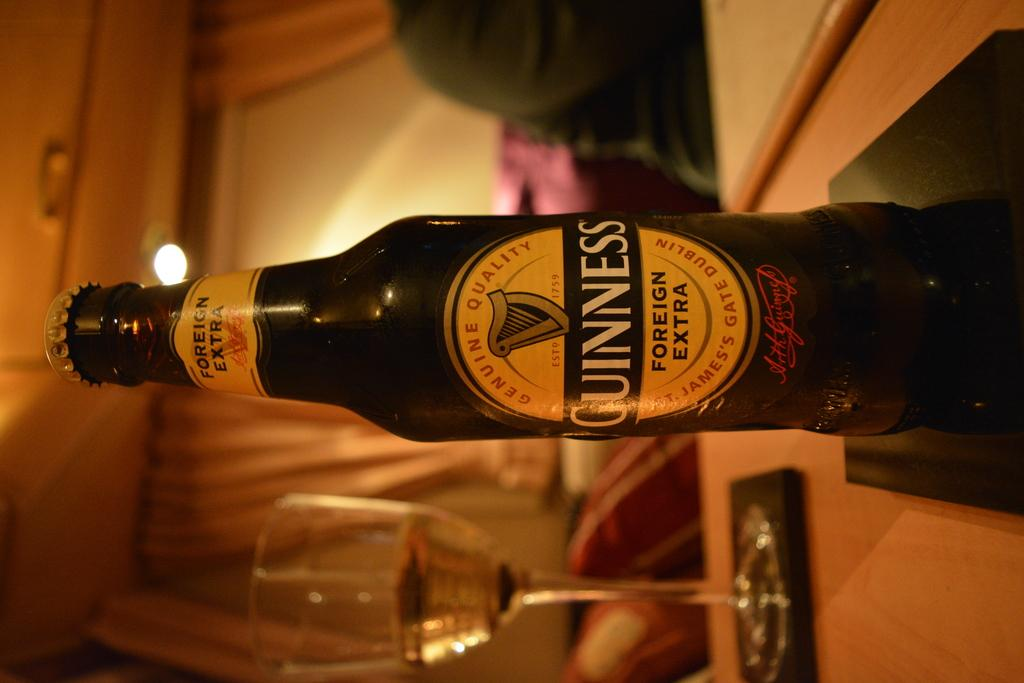<image>
Summarize the visual content of the image. A bottle of Guinness foreign extra sits on a table. 